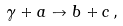<formula> <loc_0><loc_0><loc_500><loc_500>\gamma + a \to b + c \, ,</formula> 